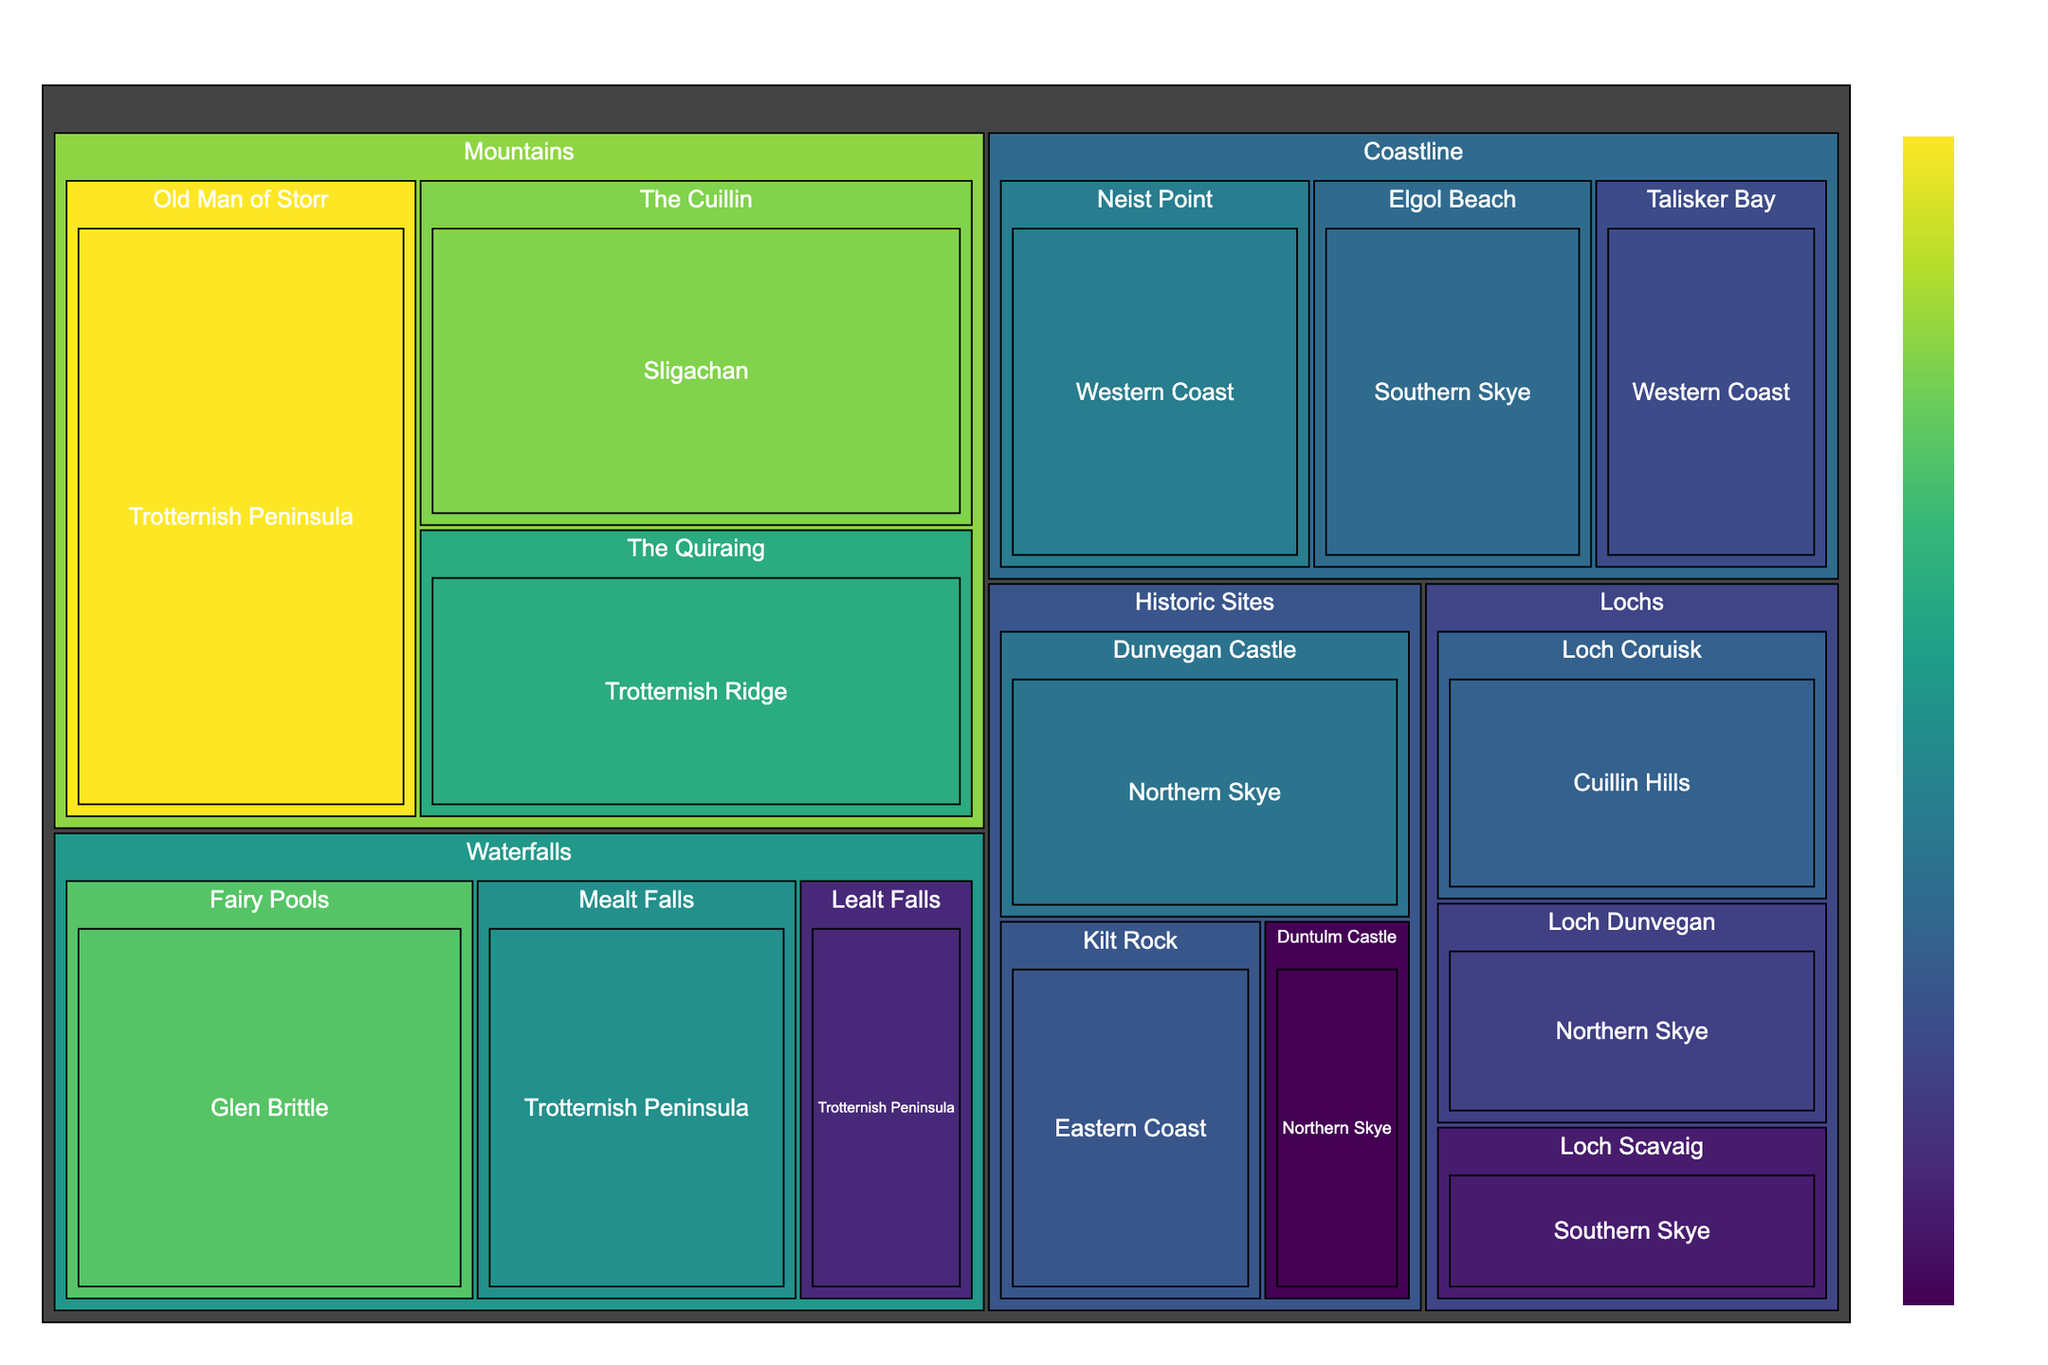what is the title of the treemap? The title is usually displayed at the top of the figure. In this case, the title is given as "Popular Photography Locations on Isle of Skye."
Answer: Popular Photography Locations on Isle of Skye how many main categories are there in the treemap? Main categories are represented as the highest-level divisions in a treemap. By checking the data, the main categories are "Mountains," "Coastline," "Waterfalls," "Lochs," and "Historic Sites."
Answer: 5 which location has the highest popularity value in the "Mountains" category? To find the location within the "Mountains" category with the highest popularity, locate the subcategory with the highest value under "Mountains"—given data shows "Old Man of Storr" has the highest value of 35.
Answer: Old Man of Storr what is the combined popularity value of all locations in the “Coastline” category? For each location under the "Coastline" category, add the values: Neist Point (20) + Talisker Bay (15) + Elgol Beach (18) = 53
Answer: 53 which subcategory under "Waterfalls" has the least popularity, and what is its value? Look for the lowest value under the "Waterfalls" category in the database. "Lealt Falls" has the least value of 12.
Answer: Lealt Falls, 12 between "Dunvegan Castle" and "Kilt Rock" in the "Historic Sites" category, which is more popular? Compare the given popularity values: Dunvegan Castle has a value of 19, and Kilt Rock has 16. Therefore, Dunvegan Castle is more popular.
Answer: Dunvegan Castle which treemap category has the largest contribution from the location with the highest individual popularity value across all categories? First identify the highest individual popularity value, which is 35 at "Old Man of Storr" under "Mountains." Hence, "Mountains" has the largest contribution.
Answer: Mountains if you were to visit locations in "Lochs," which one has the smallest popularity value, and is it greater than the least popular location in the "Historic Sites" category? “Loch Scavaig” in “Lochs” has the smallest popularity value of 11 and “Duntulm Castle” in "Historic Sites" has a value of 9. Since 11 is greater than 9, the answer is yes.
Answer: Loch Scavaig, yes what is the average popularity value of locations related to water features (Waterfalls and Lochs)? Calculate the average by summing values and dividing by the number of locations: (28+22+12) for Waterfalls and (17+14+11) for Lochs. Total = 104, number of locations = 6. Average = 104/6 = approximately 17.33.
Answer: 17.33 